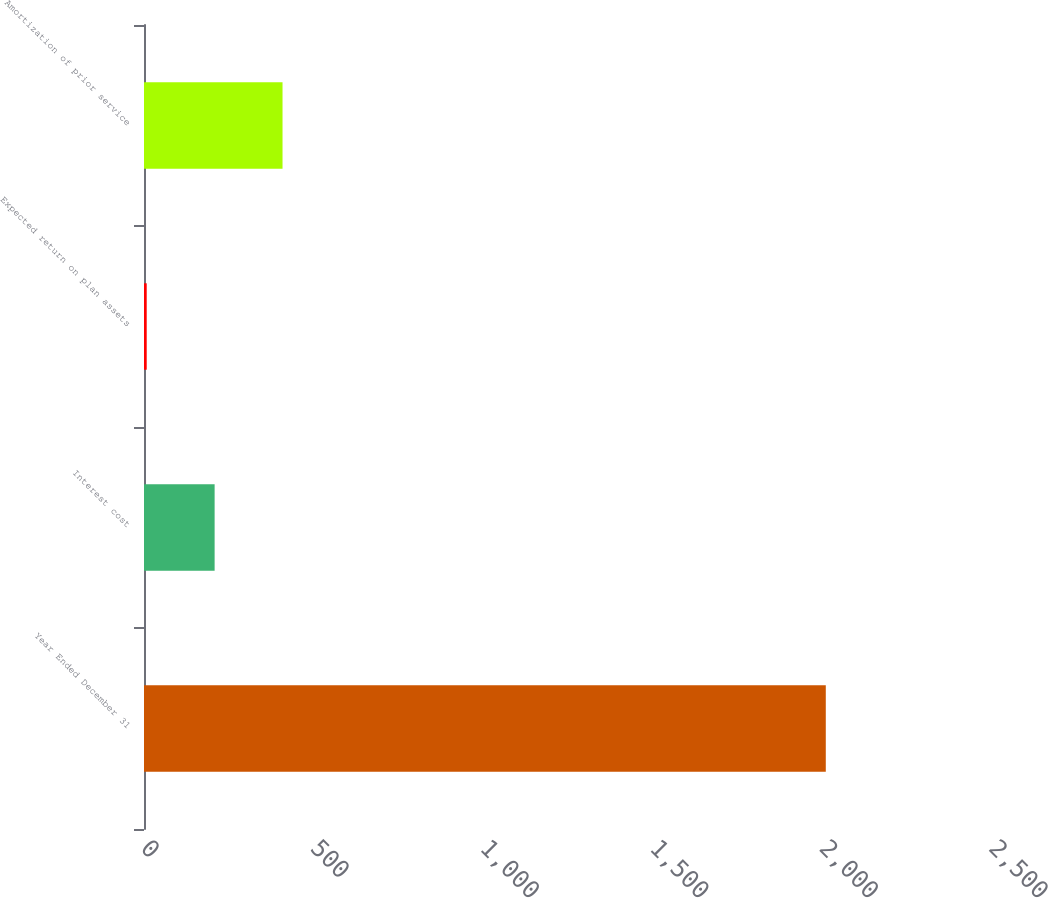Convert chart to OTSL. <chart><loc_0><loc_0><loc_500><loc_500><bar_chart><fcel>Year Ended December 31<fcel>Interest cost<fcel>Expected return on plan assets<fcel>Amortization of prior service<nl><fcel>2010<fcel>208.2<fcel>8<fcel>408.4<nl></chart> 